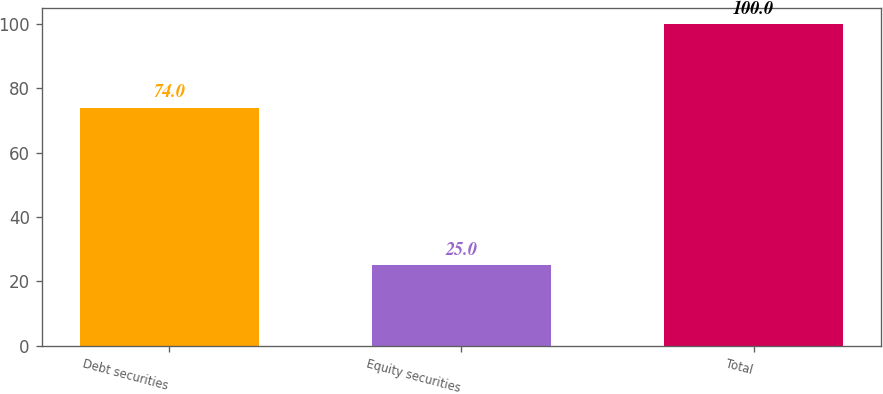Convert chart. <chart><loc_0><loc_0><loc_500><loc_500><bar_chart><fcel>Debt securities<fcel>Equity securities<fcel>Total<nl><fcel>74<fcel>25<fcel>100<nl></chart> 